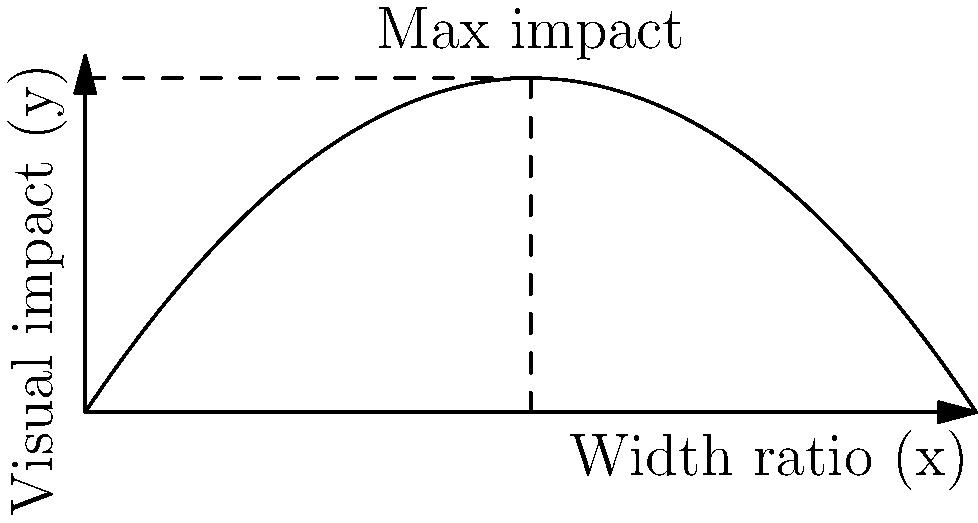As a mystic-themed graphic designer, you're designing a new tarot card. The visual impact (y) of the card is modeled by the function $y = 1.5x(1-x)$, where x is the ratio of the card's width to its height. Find the optimal width-to-height ratio that maximizes the visual impact of the tarot card. To find the optimal width-to-height ratio, we need to maximize the function $y = 1.5x(1-x)$. Here's how we can do this using calculus:

1) First, expand the function:
   $y = 1.5x - 1.5x^2$

2) To find the maximum, we need to find where the derivative equals zero. Let's calculate the derivative:
   $\frac{dy}{dx} = 1.5 - 3x$

3) Set the derivative equal to zero and solve for x:
   $1.5 - 3x = 0$
   $-3x = -1.5$
   $x = 0.5$

4) To confirm this is a maximum (not a minimum), we can check the second derivative:
   $\frac{d^2y}{dx^2} = -3$

   Since this is negative, we confirm that x = 0.5 gives a maximum.

5) Therefore, the optimal width-to-height ratio is 0.5, or 1:2.

6) We can calculate the maximum visual impact by plugging x = 0.5 into our original function:
   $y = 1.5(0.5)(1-0.5) = 1.5(0.5)(0.5) = 0.375$

This result suggests that for maximum visual impact, the tarot card should be designed with a width that is half its height.
Answer: $0.5$ (or $1:2$ width-to-height ratio) 